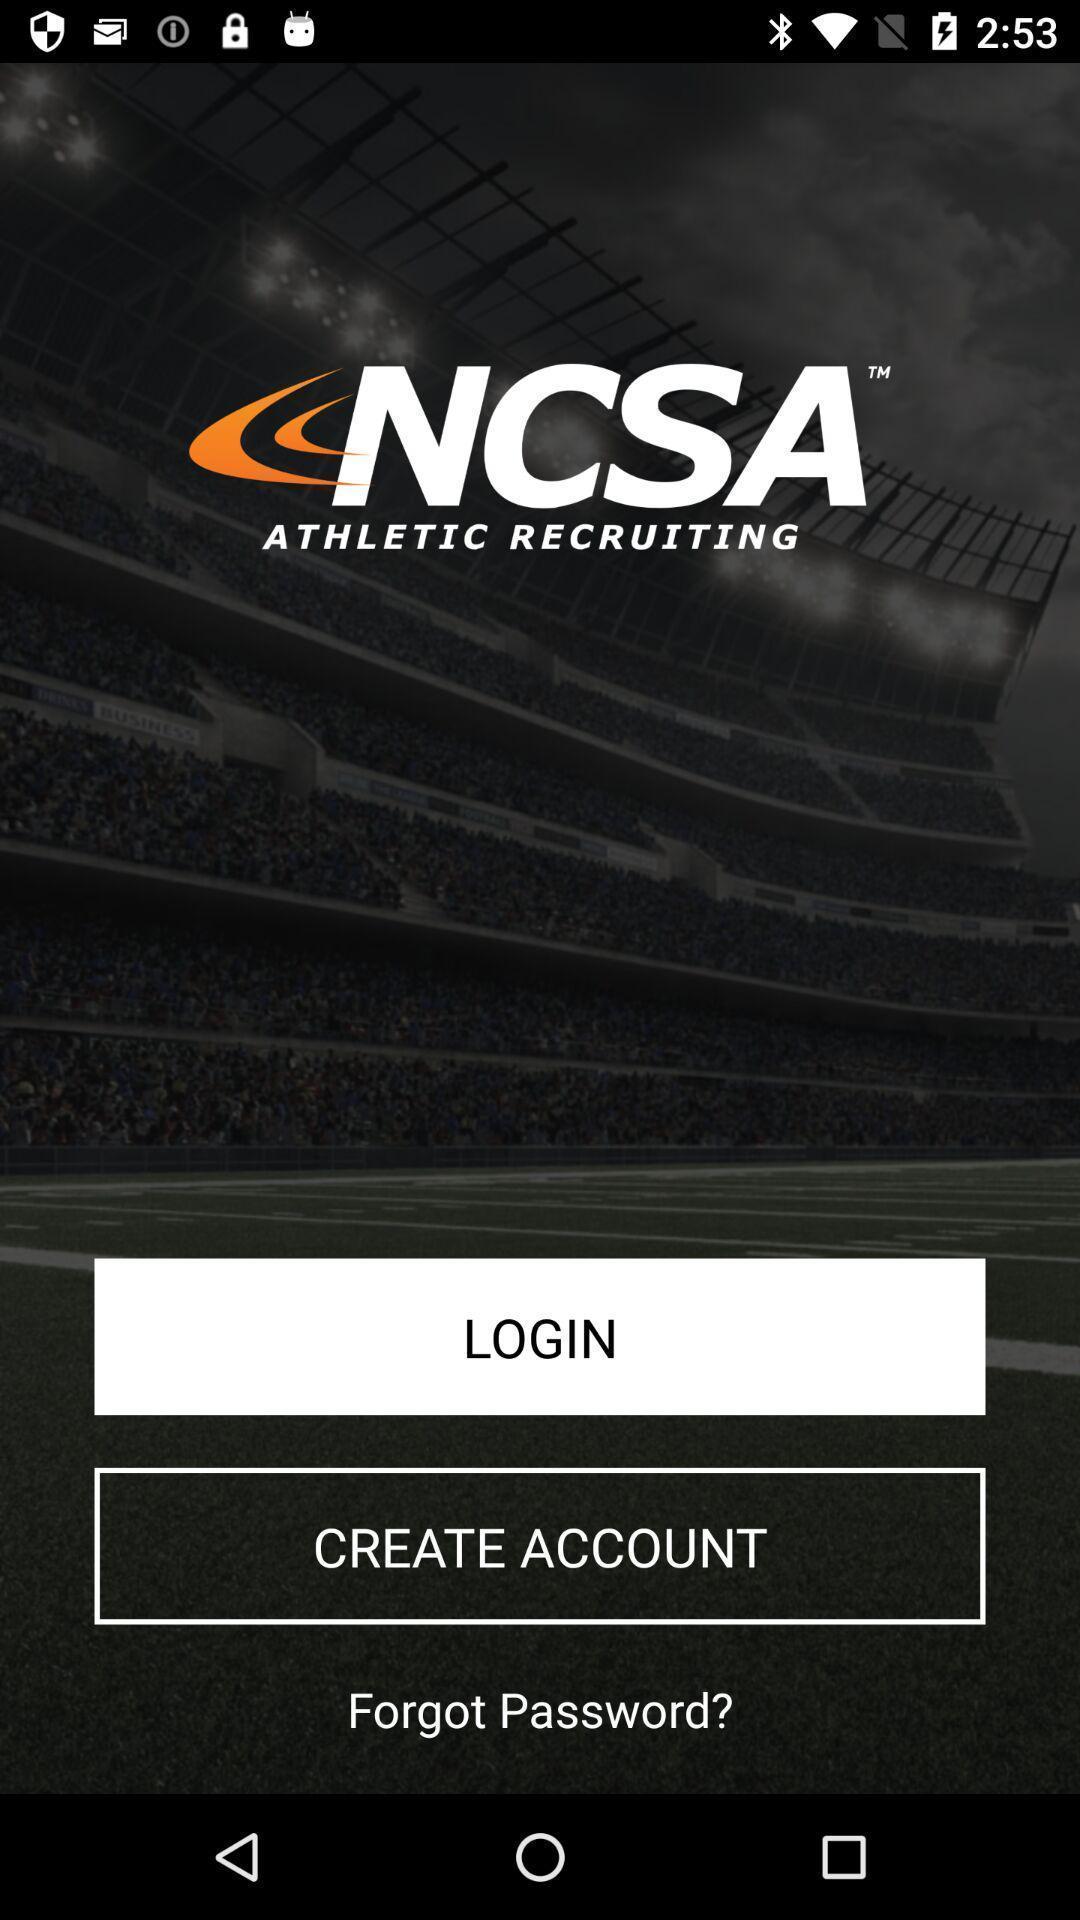Provide a textual representation of this image. Welcome page for an app. 